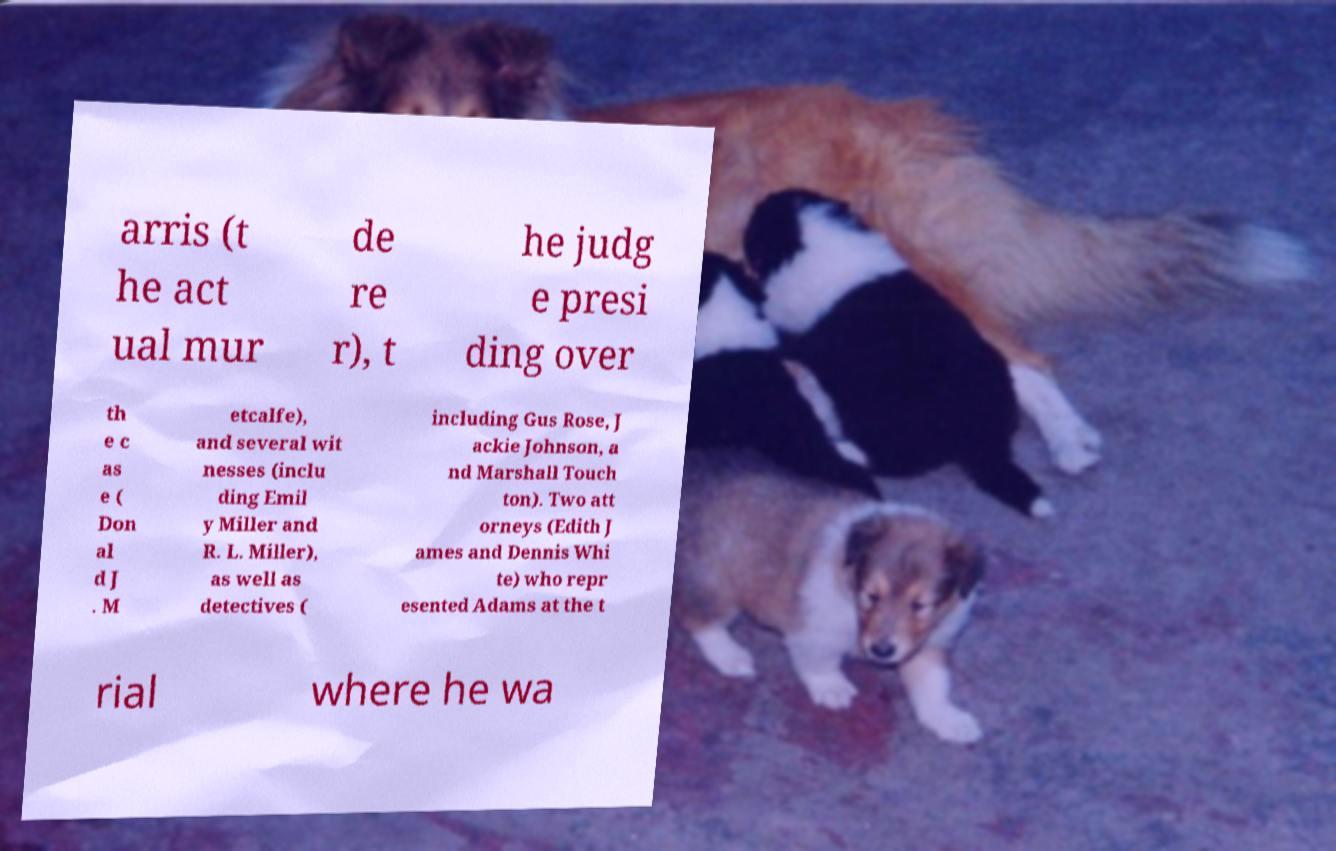Can you accurately transcribe the text from the provided image for me? arris (t he act ual mur de re r), t he judg e presi ding over th e c as e ( Don al d J . M etcalfe), and several wit nesses (inclu ding Emil y Miller and R. L. Miller), as well as detectives ( including Gus Rose, J ackie Johnson, a nd Marshall Touch ton). Two att orneys (Edith J ames and Dennis Whi te) who repr esented Adams at the t rial where he wa 